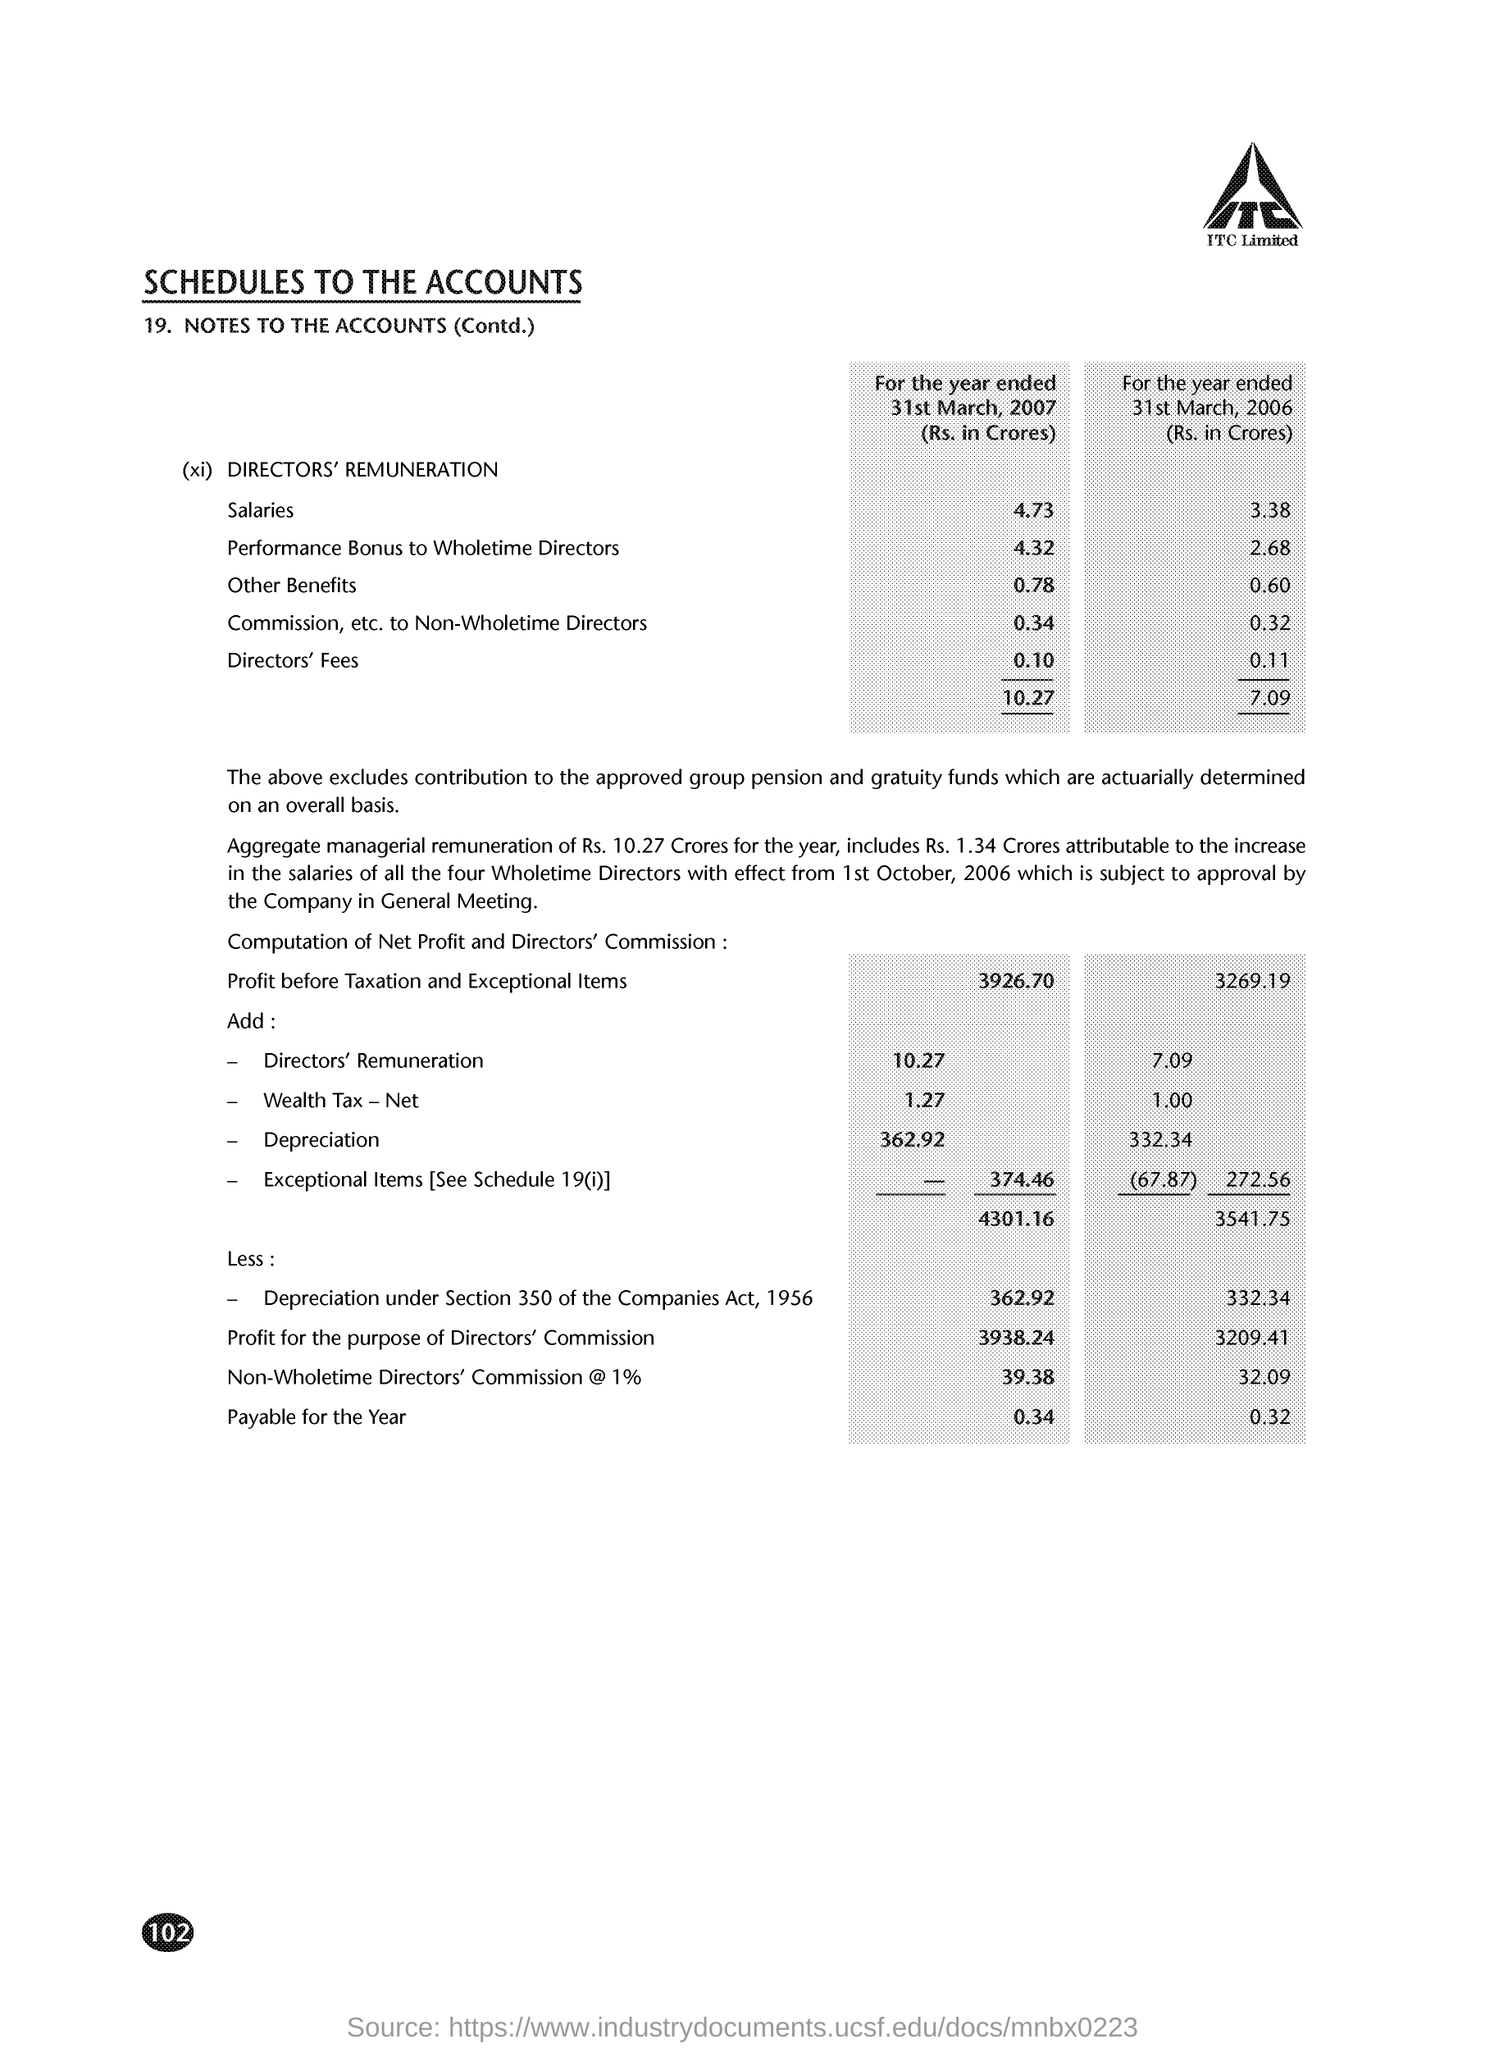What are the salaries for the year ended 31st March, 2006 (Rs. in Crores)?
Make the answer very short. 3.38. 